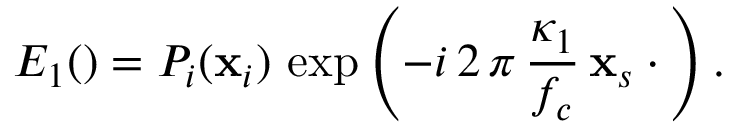Convert formula to latex. <formula><loc_0><loc_0><loc_500><loc_500>E _ { 1 } ( \ v r ) = P _ { i } ( x _ { i } ) \, \exp \left ( - i \, 2 \, \pi \, \frac { \kappa _ { 1 } } { f _ { c } } \, x _ { s } \cdot \ v r \right ) .</formula> 